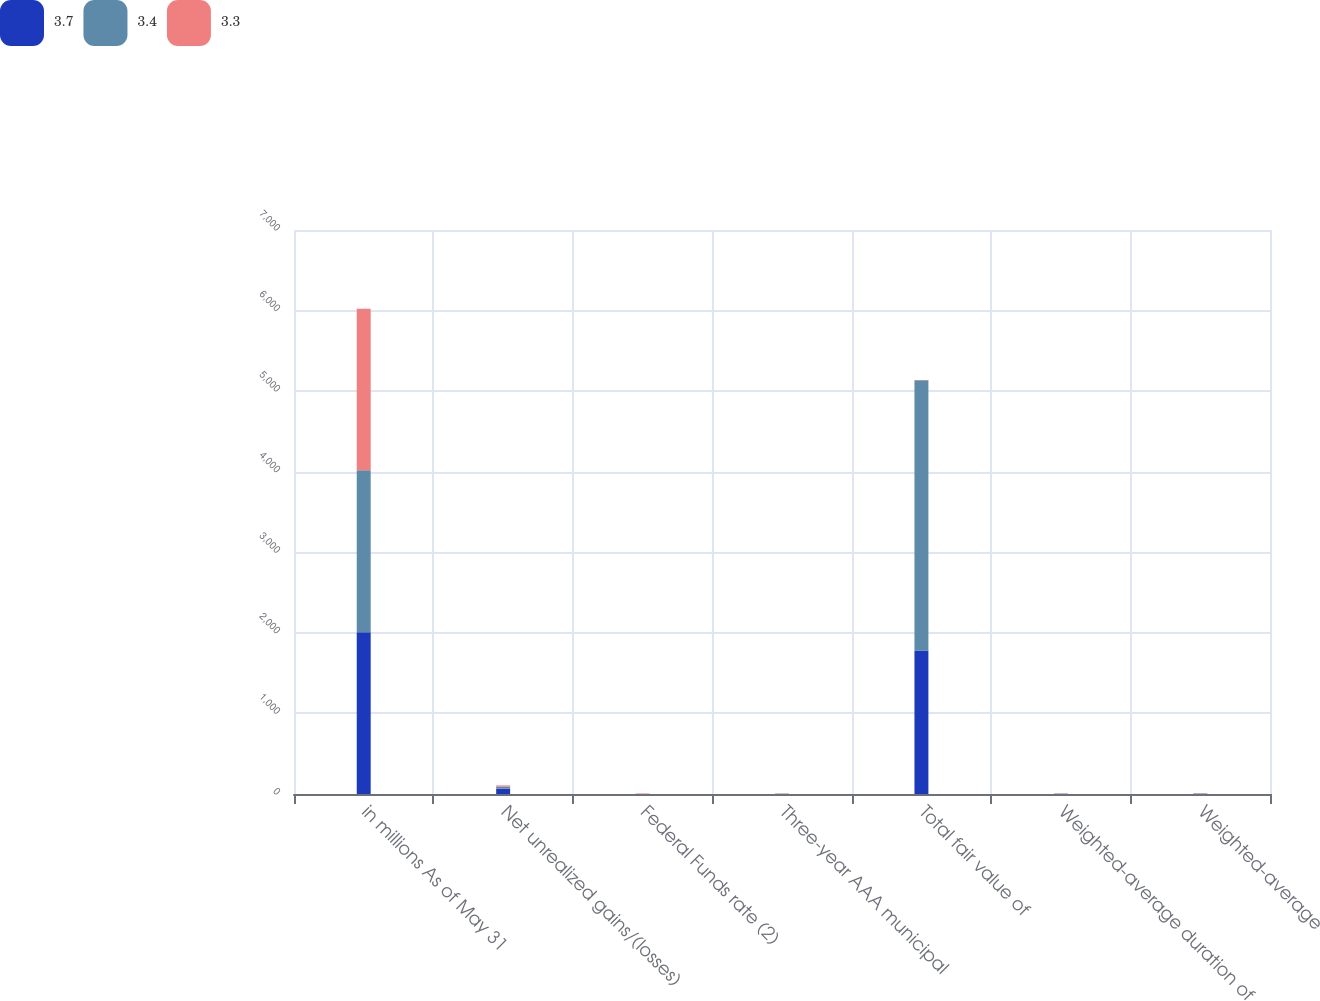Convert chart to OTSL. <chart><loc_0><loc_0><loc_500><loc_500><stacked_bar_chart><ecel><fcel>in millions As of May 31<fcel>Net unrealized gains/(losses)<fcel>Federal Funds rate (2)<fcel>Three-year AAA municipal<fcel>Total fair value of<fcel>Weighted-average duration of<fcel>Weighted-average<nl><fcel>3.7<fcel>2009<fcel>66.7<fcel>0.25<fcel>1.35<fcel>1780.9<fcel>2.5<fcel>3.3<nl><fcel>3.4<fcel>2008<fcel>24.8<fcel>2<fcel>2.65<fcel>3353.5<fcel>2.7<fcel>3.4<nl><fcel>3.3<fcel>2007<fcel>14.9<fcel>5.25<fcel>3.71<fcel>3.705<fcel>2.5<fcel>3.7<nl></chart> 